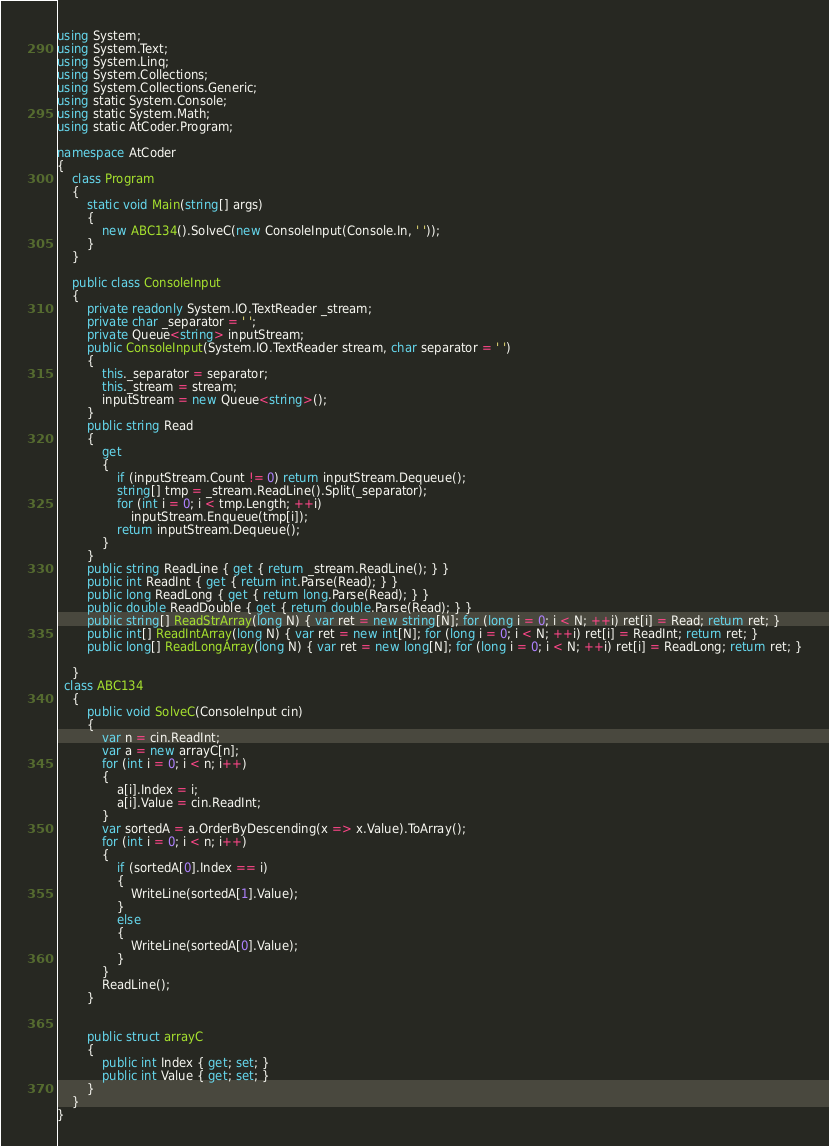<code> <loc_0><loc_0><loc_500><loc_500><_C#_>using System;
using System.Text;
using System.Linq;
using System.Collections;
using System.Collections.Generic;
using static System.Console;
using static System.Math;
using static AtCoder.Program;
 
namespace AtCoder
{
    class Program
    {
        static void Main(string[] args)
        {
            new ABC134().SolveC(new ConsoleInput(Console.In, ' '));
        }
    }
 
    public class ConsoleInput
    {
        private readonly System.IO.TextReader _stream;
        private char _separator = ' ';
        private Queue<string> inputStream;
        public ConsoleInput(System.IO.TextReader stream, char separator = ' ')
        {
            this._separator = separator;
            this._stream = stream;
            inputStream = new Queue<string>();
        }
        public string Read
        {
            get
            {
                if (inputStream.Count != 0) return inputStream.Dequeue();
                string[] tmp = _stream.ReadLine().Split(_separator);
                for (int i = 0; i < tmp.Length; ++i)
                    inputStream.Enqueue(tmp[i]);
                return inputStream.Dequeue();
            }
        }
        public string ReadLine { get { return _stream.ReadLine(); } }
        public int ReadInt { get { return int.Parse(Read); } }
        public long ReadLong { get { return long.Parse(Read); } }
        public double ReadDouble { get { return double.Parse(Read); } }
        public string[] ReadStrArray(long N) { var ret = new string[N]; for (long i = 0; i < N; ++i) ret[i] = Read; return ret; }
        public int[] ReadIntArray(long N) { var ret = new int[N]; for (long i = 0; i < N; ++i) ret[i] = ReadInt; return ret; }
        public long[] ReadLongArray(long N) { var ret = new long[N]; for (long i = 0; i < N; ++i) ret[i] = ReadLong; return ret; }
 
    }
  class ABC134
    {
        public void SolveC(ConsoleInput cin)
        {
            var n = cin.ReadInt;
            var a = new arrayC[n];
            for (int i = 0; i < n; i++)
            {
                a[i].Index = i;
                a[i].Value = cin.ReadInt;
            }
            var sortedA = a.OrderByDescending(x => x.Value).ToArray();
            for (int i = 0; i < n; i++)
            {
                if (sortedA[0].Index == i)
                {
                    WriteLine(sortedA[1].Value);
                }
                else
                {
                    WriteLine(sortedA[0].Value);
                }
            }
            ReadLine();
        }


        public struct arrayC
        {
            public int Index { get; set; }
            public int Value { get; set; }
        }
    }
}</code> 